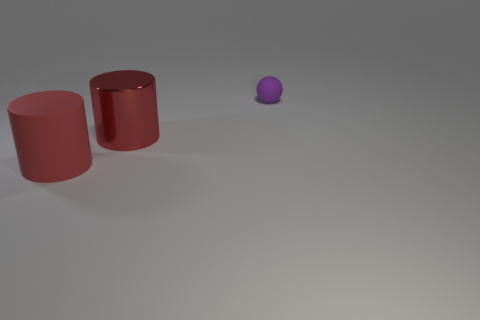Is there anything else that is the same shape as the small purple matte object?
Offer a very short reply. No. There is a object that is right of the red rubber cylinder and to the left of the tiny purple object; what is its shape?
Give a very brief answer. Cylinder. Are there fewer purple objects to the left of the small ball than tiny green rubber things?
Your answer should be very brief. No. How many tiny objects are either gray shiny cylinders or rubber objects?
Your response must be concise. 1. How big is the shiny cylinder?
Provide a succinct answer. Large. There is a large red matte object; what number of large things are on the left side of it?
Offer a very short reply. 0. The matte thing that is the same shape as the metallic object is what size?
Provide a short and direct response. Large. Does the large metallic cylinder have the same color as the matte object that is to the left of the small purple rubber sphere?
Ensure brevity in your answer.  Yes. How many purple objects are either big rubber things or matte objects?
Make the answer very short. 1. What shape is the large red metallic object?
Your answer should be very brief. Cylinder. 